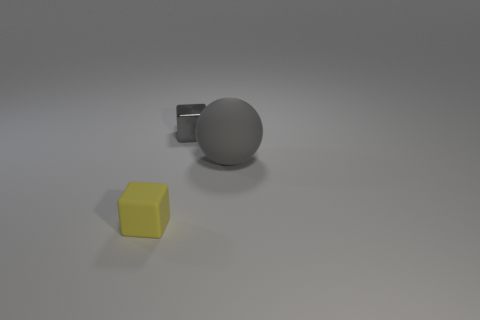There is a thing that is behind the yellow rubber cube and on the left side of the gray sphere; what material is it?
Your answer should be very brief. Metal. There is a thing that is both behind the yellow rubber object and to the left of the big rubber ball; what size is it?
Ensure brevity in your answer.  Small. There is a gray metal thing that is the same size as the rubber block; what shape is it?
Make the answer very short. Cube. How many other objects are the same color as the large matte ball?
Keep it short and to the point. 1. There is a rubber object that is on the left side of the tiny thing behind the tiny yellow rubber object; what size is it?
Offer a very short reply. Small. Is the object that is in front of the matte sphere made of the same material as the big object?
Keep it short and to the point. Yes. What is the shape of the matte object to the left of the small gray block?
Make the answer very short. Cube. How many other yellow blocks are the same size as the yellow cube?
Your answer should be very brief. 0. How big is the gray metallic thing?
Provide a short and direct response. Small. How many gray objects are to the left of the large thing?
Your answer should be very brief. 1. 